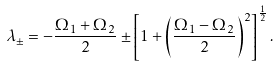<formula> <loc_0><loc_0><loc_500><loc_500>\lambda _ { \pm } = - \frac { \Omega _ { 1 } + \Omega _ { 2 } } { 2 } \pm \left [ 1 + \left ( \frac { \Omega _ { 1 } - \Omega _ { 2 } } { 2 } \right ) ^ { 2 } \right ] ^ { \frac { 1 } { 2 } } .</formula> 